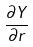<formula> <loc_0><loc_0><loc_500><loc_500>\frac { \partial Y } { \partial r }</formula> 